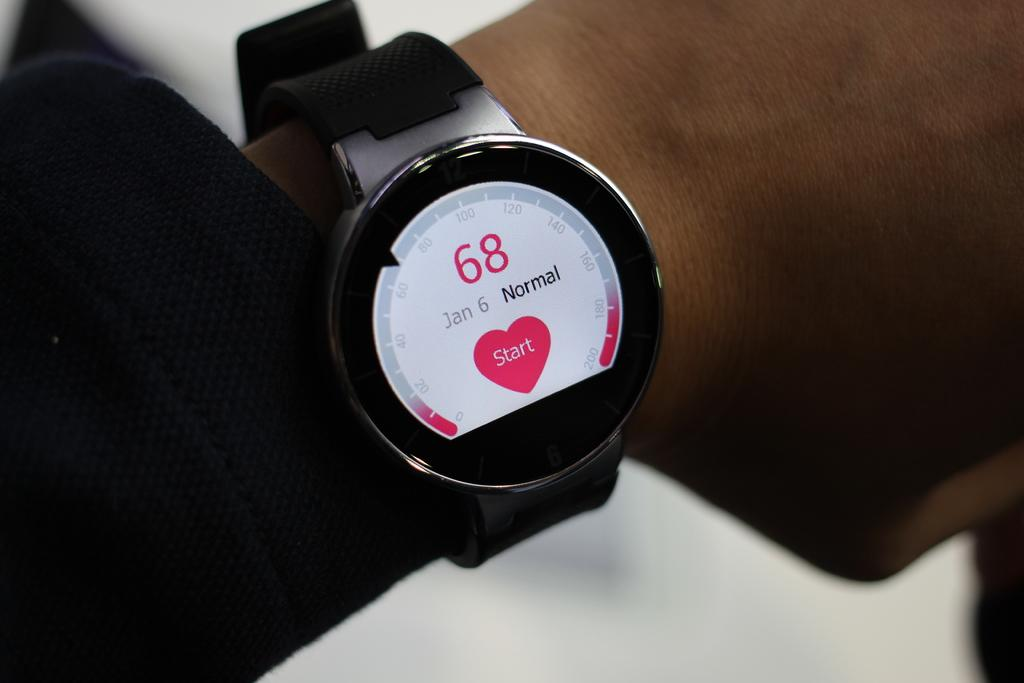<image>
Give a short and clear explanation of the subsequent image. A smart watch the number 68 and a pink heart that says start in the middle in on somebody's wrist 